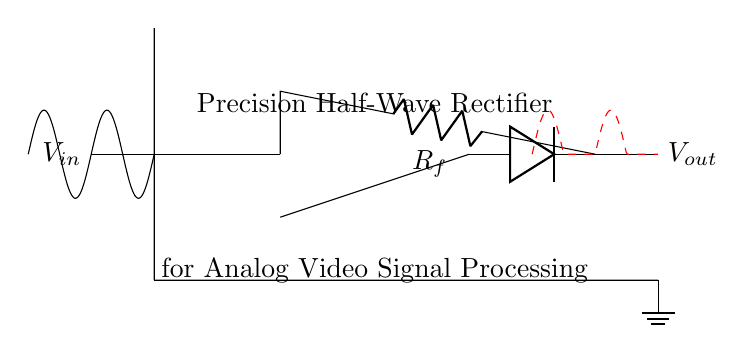What is the primary function of the circuit? The primary function is to convert an AC input signal into a unidirectional DC output signal through rectification.
Answer: Rectification What type of rectifier is used in this circuit? This circuit utilizes a precision half-wave rectifier, which allows for accurate low-level signal processing.
Answer: Half-wave What is the purpose of the diode in this circuit? The diode allows current to pass in only one direction, which is essential for converting the AC input into a DC output while blocking negative portions of the waveform.
Answer: Blocking negative current What component is used for feedback in the op-amp configuration? The feedback resistor, denoted as Rf, is used to provide feedback to the op-amp, ultimately influencing the gain and operation of the precision rectifier.
Answer: Feedback resistor What happens to the negative portion of the input waveform? The negative portion of the input waveform is effectively clamped to zero output, resulting in the output waveform only reflecting the positive part of the input signal.
Answer: Clamped to zero How does this circuit affect the amplitude of the output signal? The circuit can maintain the amplitude of the positive portion of the input signal, providing an output that closely follows the input without significant loss, depending on the feedback resistor value.
Answer: Maintains amplitude What type of signals is this circuit particularly designed to process? This precision half-wave rectifier is particularly designed for low-level analog video signals, ensuring suitability for video signal processing tasks.
Answer: Analog video signals 